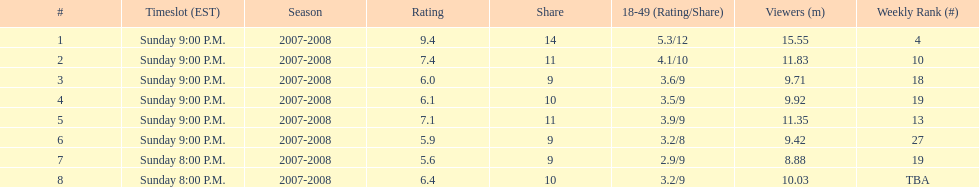Parse the table in full. {'header': ['#', 'Timeslot (EST)', 'Season', 'Rating', 'Share', '18-49 (Rating/Share)', 'Viewers (m)', 'Weekly Rank (#)'], 'rows': [['1', 'Sunday 9:00 P.M.', '2007-2008', '9.4', '14', '5.3/12', '15.55', '4'], ['2', 'Sunday 9:00 P.M.', '2007-2008', '7.4', '11', '4.1/10', '11.83', '10'], ['3', 'Sunday 9:00 P.M.', '2007-2008', '6.0', '9', '3.6/9', '9.71', '18'], ['4', 'Sunday 9:00 P.M.', '2007-2008', '6.1', '10', '3.5/9', '9.92', '19'], ['5', 'Sunday 9:00 P.M.', '2007-2008', '7.1', '11', '3.9/9', '11.35', '13'], ['6', 'Sunday 9:00 P.M.', '2007-2008', '5.9', '9', '3.2/8', '9.42', '27'], ['7', 'Sunday 8:00 P.M.', '2007-2008', '5.6', '9', '2.9/9', '8.88', '19'], ['8', 'Sunday 8:00 P.M.', '2007-2008', '6.4', '10', '3.2/9', '10.03', 'TBA']]} Which show had the highest rating? 1. 